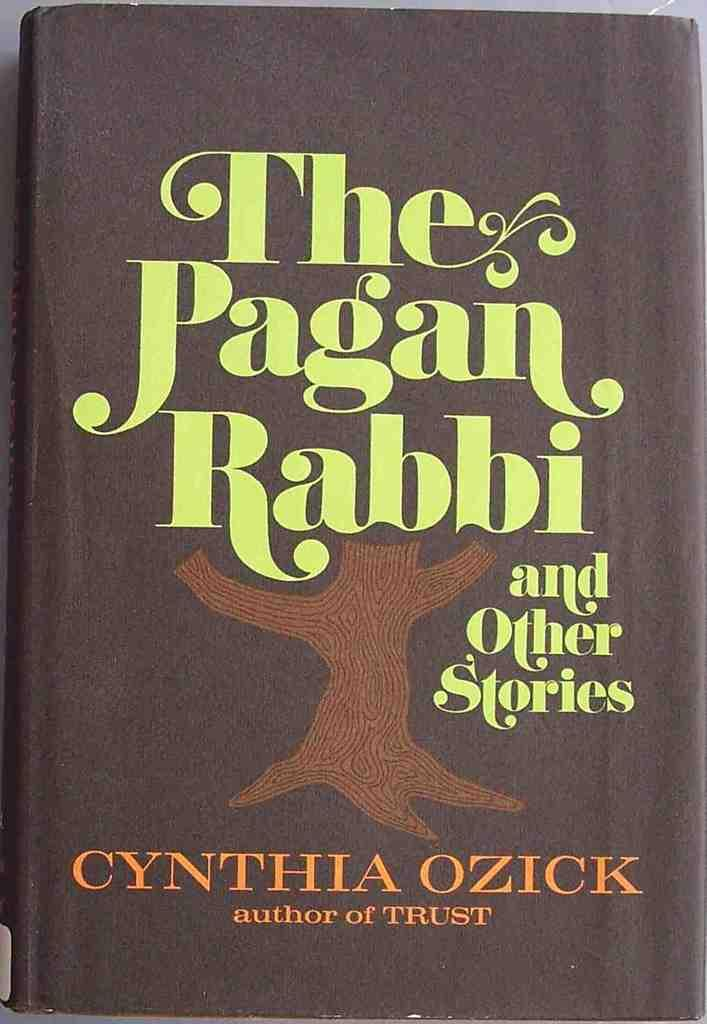<image>
Offer a succinct explanation of the picture presented. A book called "the Pagan Rabbi" is shown close up. 